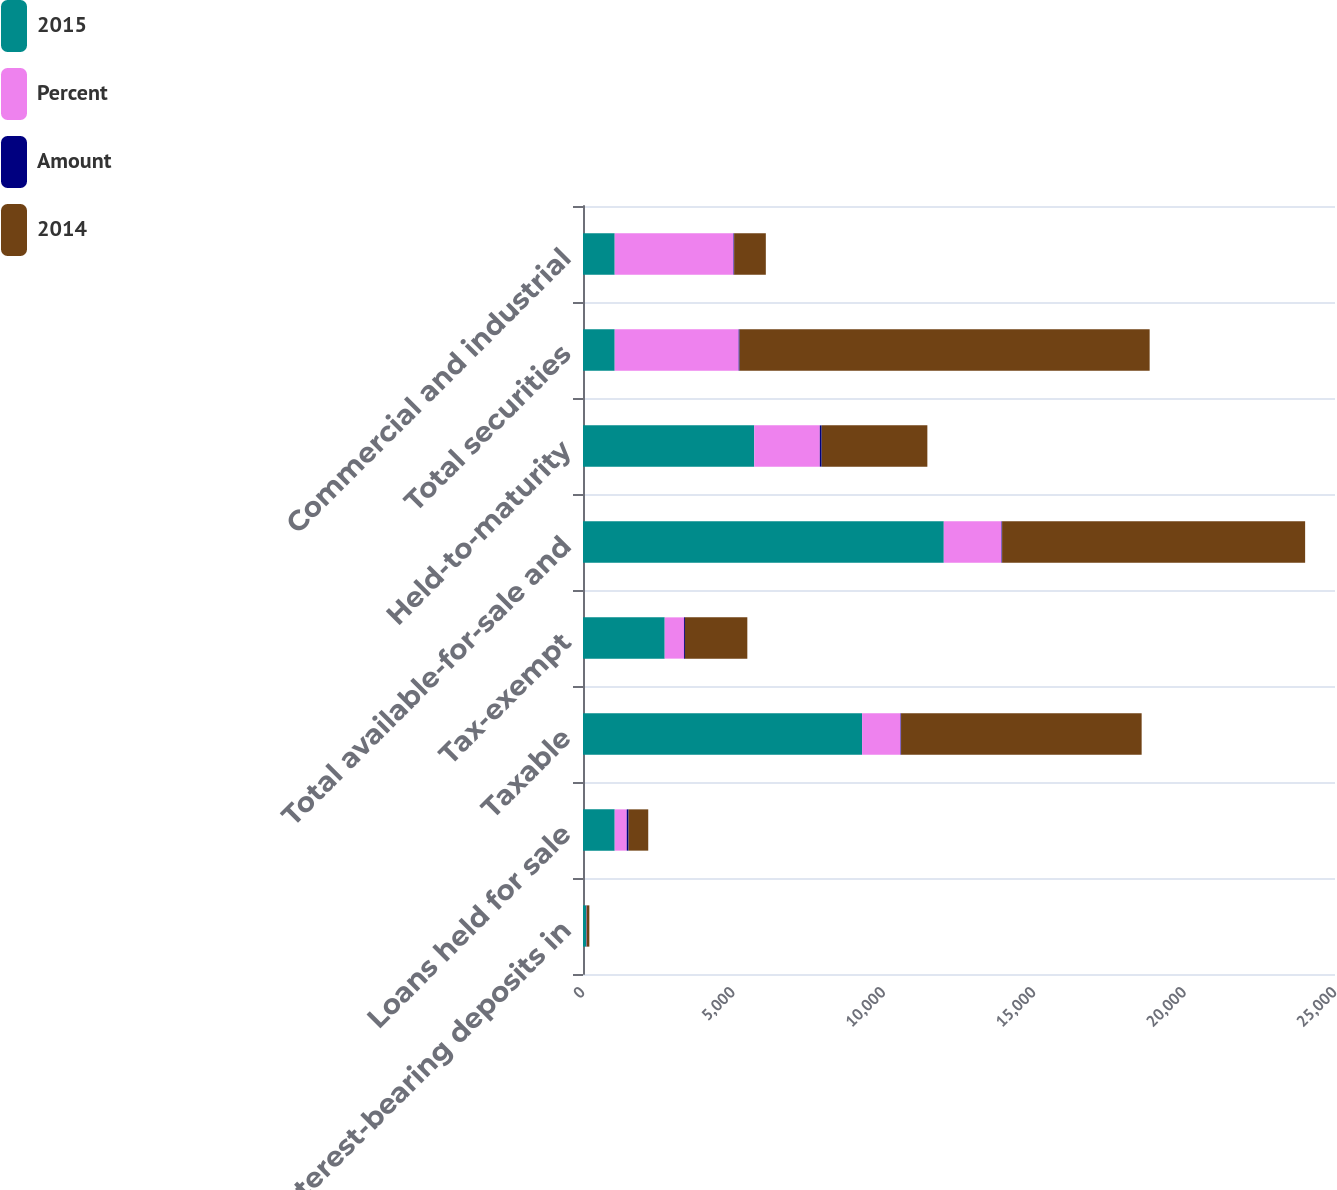Convert chart to OTSL. <chart><loc_0><loc_0><loc_500><loc_500><stacked_bar_chart><ecel><fcel>Interest-bearing deposits in<fcel>Loans held for sale<fcel>Taxable<fcel>Tax-exempt<fcel>Total available-for-sale and<fcel>Held-to-maturity<fcel>Total securities<fcel>Commercial and industrial<nl><fcel>2015<fcel>100<fcel>1054<fcel>9278<fcel>2716<fcel>11994<fcel>5693<fcel>1054<fcel>1054<nl><fcel>Percent<fcel>10<fcel>400<fcel>1279<fcel>641<fcel>1920<fcel>2180<fcel>4121<fcel>3950<nl><fcel>Amount<fcel>11<fcel>61<fcel>16<fcel>31<fcel>19<fcel>62<fcel>30<fcel>20<nl><fcel>2014<fcel>90<fcel>654<fcel>7999<fcel>2075<fcel>10074<fcel>3513<fcel>13633<fcel>1054<nl></chart> 